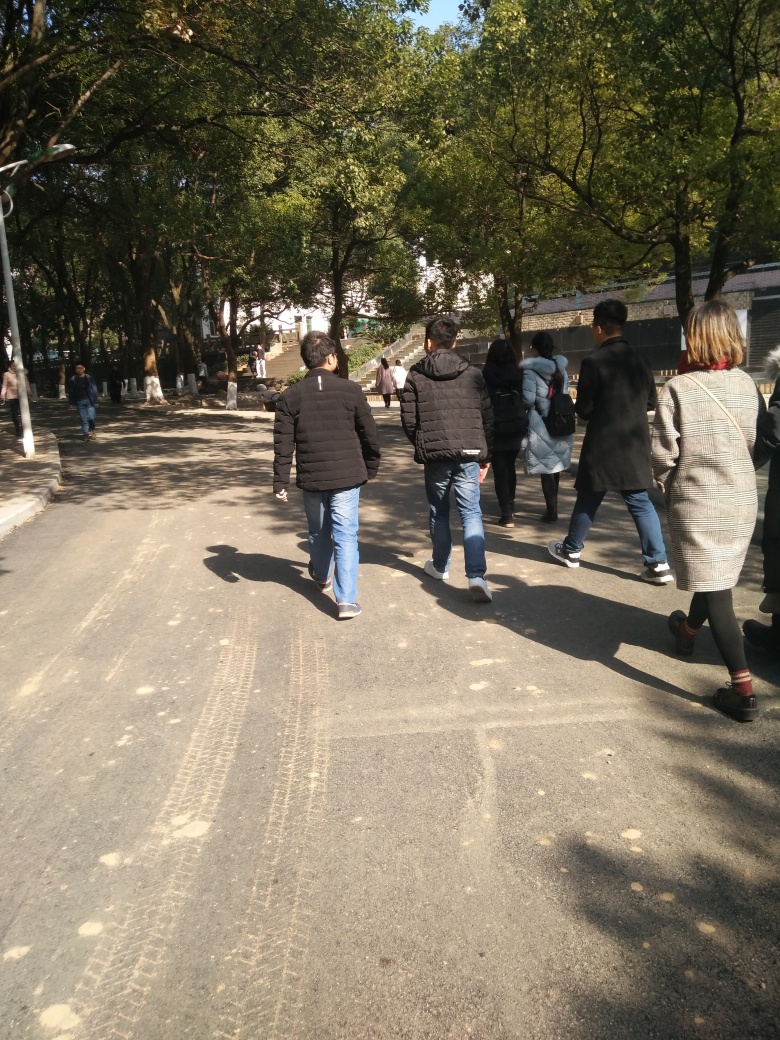Are there any landmarks or structures that might indicate where this place is? No distinctive landmarks or structures are immediately visible in the image that would reveal the exact location. However, the style of clothing and the architecture in the distance could potentially narrow the geographical context with further research. 